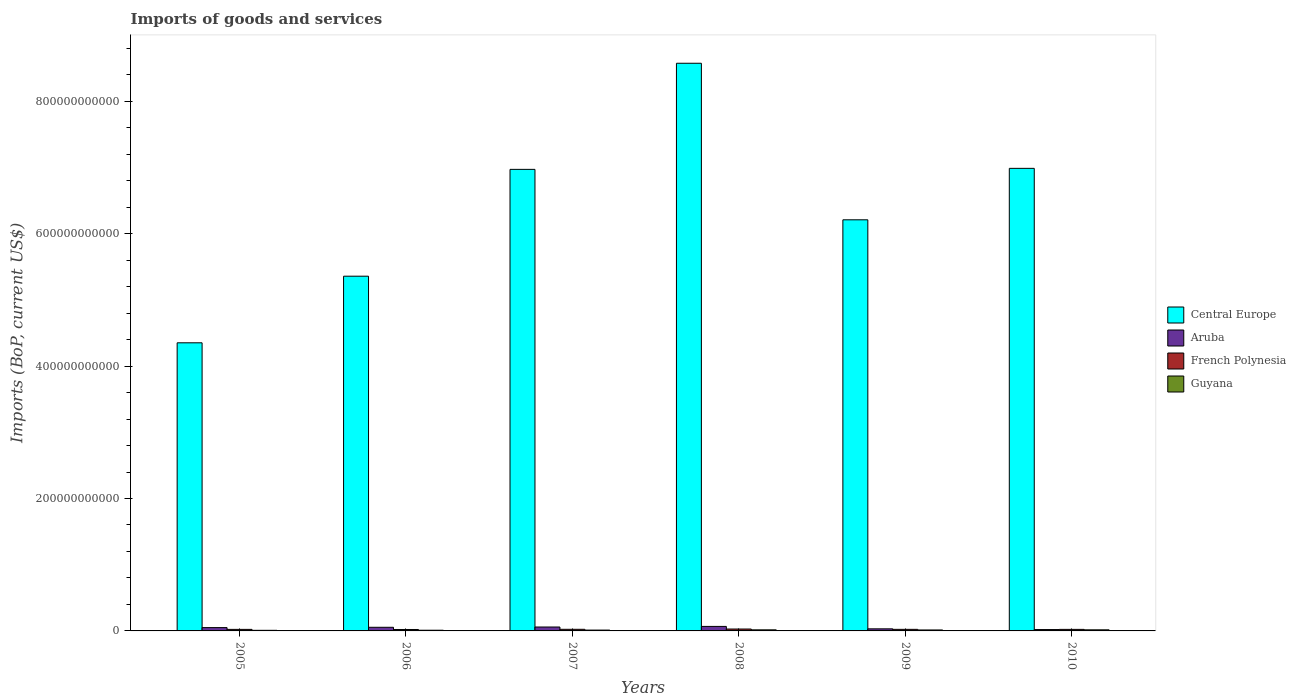How many different coloured bars are there?
Offer a terse response. 4. How many groups of bars are there?
Your response must be concise. 6. Are the number of bars per tick equal to the number of legend labels?
Your answer should be very brief. Yes. In how many cases, is the number of bars for a given year not equal to the number of legend labels?
Your answer should be very brief. 0. What is the amount spent on imports in French Polynesia in 2005?
Provide a succinct answer. 2.31e+09. Across all years, what is the maximum amount spent on imports in French Polynesia?
Offer a terse response. 2.87e+09. Across all years, what is the minimum amount spent on imports in Guyana?
Give a very brief answer. 9.18e+08. In which year was the amount spent on imports in Guyana maximum?
Provide a succinct answer. 2010. In which year was the amount spent on imports in Central Europe minimum?
Offer a terse response. 2005. What is the total amount spent on imports in French Polynesia in the graph?
Provide a short and direct response. 1.45e+1. What is the difference between the amount spent on imports in Aruba in 2006 and that in 2008?
Make the answer very short. -1.33e+09. What is the difference between the amount spent on imports in Guyana in 2007 and the amount spent on imports in Central Europe in 2006?
Offer a very short reply. -5.35e+11. What is the average amount spent on imports in Central Europe per year?
Keep it short and to the point. 6.41e+11. In the year 2006, what is the difference between the amount spent on imports in Aruba and amount spent on imports in Central Europe?
Offer a very short reply. -5.30e+11. In how many years, is the amount spent on imports in Central Europe greater than 840000000000 US$?
Keep it short and to the point. 1. What is the ratio of the amount spent on imports in Central Europe in 2009 to that in 2010?
Keep it short and to the point. 0.89. Is the amount spent on imports in Central Europe in 2005 less than that in 2008?
Offer a terse response. Yes. Is the difference between the amount spent on imports in Aruba in 2009 and 2010 greater than the difference between the amount spent on imports in Central Europe in 2009 and 2010?
Your response must be concise. Yes. What is the difference between the highest and the second highest amount spent on imports in Guyana?
Offer a terse response. 8.76e+06. What is the difference between the highest and the lowest amount spent on imports in French Polynesia?
Make the answer very short. 7.10e+08. What does the 1st bar from the left in 2007 represents?
Provide a short and direct response. Central Europe. What does the 3rd bar from the right in 2008 represents?
Your response must be concise. Aruba. How many bars are there?
Provide a succinct answer. 24. Are all the bars in the graph horizontal?
Make the answer very short. No. How many years are there in the graph?
Keep it short and to the point. 6. What is the difference between two consecutive major ticks on the Y-axis?
Keep it short and to the point. 2.00e+11. Are the values on the major ticks of Y-axis written in scientific E-notation?
Ensure brevity in your answer.  No. Where does the legend appear in the graph?
Give a very brief answer. Center right. What is the title of the graph?
Provide a succinct answer. Imports of goods and services. What is the label or title of the Y-axis?
Give a very brief answer. Imports (BoP, current US$). What is the Imports (BoP, current US$) in Central Europe in 2005?
Offer a very short reply. 4.35e+11. What is the Imports (BoP, current US$) of Aruba in 2005?
Your response must be concise. 5.01e+09. What is the Imports (BoP, current US$) in French Polynesia in 2005?
Provide a short and direct response. 2.31e+09. What is the Imports (BoP, current US$) in Guyana in 2005?
Your response must be concise. 9.18e+08. What is the Imports (BoP, current US$) in Central Europe in 2006?
Offer a terse response. 5.36e+11. What is the Imports (BoP, current US$) of Aruba in 2006?
Your answer should be compact. 5.48e+09. What is the Imports (BoP, current US$) of French Polynesia in 2006?
Your answer should be very brief. 2.16e+09. What is the Imports (BoP, current US$) in Guyana in 2006?
Offer a very short reply. 1.06e+09. What is the Imports (BoP, current US$) of Central Europe in 2007?
Your answer should be compact. 6.97e+11. What is the Imports (BoP, current US$) in Aruba in 2007?
Provide a succinct answer. 5.91e+09. What is the Imports (BoP, current US$) in French Polynesia in 2007?
Provide a short and direct response. 2.43e+09. What is the Imports (BoP, current US$) of Guyana in 2007?
Your response must be concise. 1.26e+09. What is the Imports (BoP, current US$) of Central Europe in 2008?
Offer a terse response. 8.57e+11. What is the Imports (BoP, current US$) of Aruba in 2008?
Provide a succinct answer. 6.81e+09. What is the Imports (BoP, current US$) of French Polynesia in 2008?
Keep it short and to the point. 2.87e+09. What is the Imports (BoP, current US$) in Guyana in 2008?
Provide a short and direct response. 1.65e+09. What is the Imports (BoP, current US$) in Central Europe in 2009?
Give a very brief answer. 6.21e+11. What is the Imports (BoP, current US$) in Aruba in 2009?
Make the answer very short. 3.15e+09. What is the Imports (BoP, current US$) in French Polynesia in 2009?
Your response must be concise. 2.38e+09. What is the Imports (BoP, current US$) of Guyana in 2009?
Offer a terse response. 1.45e+09. What is the Imports (BoP, current US$) of Central Europe in 2010?
Ensure brevity in your answer.  6.99e+11. What is the Imports (BoP, current US$) in Aruba in 2010?
Your answer should be compact. 2.07e+09. What is the Imports (BoP, current US$) in French Polynesia in 2010?
Your response must be concise. 2.33e+09. What is the Imports (BoP, current US$) in Guyana in 2010?
Keep it short and to the point. 1.66e+09. Across all years, what is the maximum Imports (BoP, current US$) in Central Europe?
Provide a short and direct response. 8.57e+11. Across all years, what is the maximum Imports (BoP, current US$) of Aruba?
Provide a succinct answer. 6.81e+09. Across all years, what is the maximum Imports (BoP, current US$) in French Polynesia?
Your answer should be compact. 2.87e+09. Across all years, what is the maximum Imports (BoP, current US$) of Guyana?
Ensure brevity in your answer.  1.66e+09. Across all years, what is the minimum Imports (BoP, current US$) of Central Europe?
Give a very brief answer. 4.35e+11. Across all years, what is the minimum Imports (BoP, current US$) in Aruba?
Ensure brevity in your answer.  2.07e+09. Across all years, what is the minimum Imports (BoP, current US$) of French Polynesia?
Your answer should be compact. 2.16e+09. Across all years, what is the minimum Imports (BoP, current US$) in Guyana?
Make the answer very short. 9.18e+08. What is the total Imports (BoP, current US$) of Central Europe in the graph?
Your response must be concise. 3.85e+12. What is the total Imports (BoP, current US$) in Aruba in the graph?
Offer a terse response. 2.84e+1. What is the total Imports (BoP, current US$) in French Polynesia in the graph?
Your answer should be compact. 1.45e+1. What is the total Imports (BoP, current US$) of Guyana in the graph?
Provide a short and direct response. 7.99e+09. What is the difference between the Imports (BoP, current US$) of Central Europe in 2005 and that in 2006?
Provide a short and direct response. -1.01e+11. What is the difference between the Imports (BoP, current US$) of Aruba in 2005 and that in 2006?
Make the answer very short. -4.72e+08. What is the difference between the Imports (BoP, current US$) of French Polynesia in 2005 and that in 2006?
Make the answer very short. 1.59e+08. What is the difference between the Imports (BoP, current US$) of Guyana in 2005 and that in 2006?
Your answer should be very brief. -1.37e+08. What is the difference between the Imports (BoP, current US$) of Central Europe in 2005 and that in 2007?
Keep it short and to the point. -2.62e+11. What is the difference between the Imports (BoP, current US$) in Aruba in 2005 and that in 2007?
Your answer should be very brief. -9.04e+08. What is the difference between the Imports (BoP, current US$) in French Polynesia in 2005 and that in 2007?
Make the answer very short. -1.17e+08. What is the difference between the Imports (BoP, current US$) in Guyana in 2005 and that in 2007?
Your answer should be very brief. -3.37e+08. What is the difference between the Imports (BoP, current US$) in Central Europe in 2005 and that in 2008?
Your answer should be compact. -4.22e+11. What is the difference between the Imports (BoP, current US$) in Aruba in 2005 and that in 2008?
Offer a terse response. -1.80e+09. What is the difference between the Imports (BoP, current US$) of French Polynesia in 2005 and that in 2008?
Your response must be concise. -5.50e+08. What is the difference between the Imports (BoP, current US$) of Guyana in 2005 and that in 2008?
Your answer should be very brief. -7.31e+08. What is the difference between the Imports (BoP, current US$) of Central Europe in 2005 and that in 2009?
Offer a very short reply. -1.86e+11. What is the difference between the Imports (BoP, current US$) of Aruba in 2005 and that in 2009?
Make the answer very short. 1.86e+09. What is the difference between the Imports (BoP, current US$) in French Polynesia in 2005 and that in 2009?
Your answer should be compact. -6.25e+07. What is the difference between the Imports (BoP, current US$) in Guyana in 2005 and that in 2009?
Provide a short and direct response. -5.34e+08. What is the difference between the Imports (BoP, current US$) in Central Europe in 2005 and that in 2010?
Offer a terse response. -2.63e+11. What is the difference between the Imports (BoP, current US$) of Aruba in 2005 and that in 2010?
Make the answer very short. 2.93e+09. What is the difference between the Imports (BoP, current US$) in French Polynesia in 2005 and that in 2010?
Give a very brief answer. -1.53e+07. What is the difference between the Imports (BoP, current US$) in Guyana in 2005 and that in 2010?
Make the answer very short. -7.40e+08. What is the difference between the Imports (BoP, current US$) of Central Europe in 2006 and that in 2007?
Offer a very short reply. -1.61e+11. What is the difference between the Imports (BoP, current US$) in Aruba in 2006 and that in 2007?
Provide a short and direct response. -4.32e+08. What is the difference between the Imports (BoP, current US$) of French Polynesia in 2006 and that in 2007?
Give a very brief answer. -2.76e+08. What is the difference between the Imports (BoP, current US$) of Guyana in 2006 and that in 2007?
Provide a succinct answer. -2.00e+08. What is the difference between the Imports (BoP, current US$) of Central Europe in 2006 and that in 2008?
Ensure brevity in your answer.  -3.22e+11. What is the difference between the Imports (BoP, current US$) of Aruba in 2006 and that in 2008?
Make the answer very short. -1.33e+09. What is the difference between the Imports (BoP, current US$) in French Polynesia in 2006 and that in 2008?
Keep it short and to the point. -7.10e+08. What is the difference between the Imports (BoP, current US$) in Guyana in 2006 and that in 2008?
Offer a very short reply. -5.94e+08. What is the difference between the Imports (BoP, current US$) of Central Europe in 2006 and that in 2009?
Give a very brief answer. -8.52e+1. What is the difference between the Imports (BoP, current US$) of Aruba in 2006 and that in 2009?
Provide a short and direct response. 2.33e+09. What is the difference between the Imports (BoP, current US$) in French Polynesia in 2006 and that in 2009?
Make the answer very short. -2.22e+08. What is the difference between the Imports (BoP, current US$) of Guyana in 2006 and that in 2009?
Your response must be concise. -3.97e+08. What is the difference between the Imports (BoP, current US$) of Central Europe in 2006 and that in 2010?
Give a very brief answer. -1.63e+11. What is the difference between the Imports (BoP, current US$) in Aruba in 2006 and that in 2010?
Your answer should be compact. 3.41e+09. What is the difference between the Imports (BoP, current US$) in French Polynesia in 2006 and that in 2010?
Make the answer very short. -1.75e+08. What is the difference between the Imports (BoP, current US$) of Guyana in 2006 and that in 2010?
Give a very brief answer. -6.02e+08. What is the difference between the Imports (BoP, current US$) of Central Europe in 2007 and that in 2008?
Provide a short and direct response. -1.60e+11. What is the difference between the Imports (BoP, current US$) in Aruba in 2007 and that in 2008?
Give a very brief answer. -9.00e+08. What is the difference between the Imports (BoP, current US$) of French Polynesia in 2007 and that in 2008?
Provide a succinct answer. -4.33e+08. What is the difference between the Imports (BoP, current US$) of Guyana in 2007 and that in 2008?
Your response must be concise. -3.93e+08. What is the difference between the Imports (BoP, current US$) in Central Europe in 2007 and that in 2009?
Offer a terse response. 7.62e+1. What is the difference between the Imports (BoP, current US$) of Aruba in 2007 and that in 2009?
Provide a short and direct response. 2.77e+09. What is the difference between the Imports (BoP, current US$) in French Polynesia in 2007 and that in 2009?
Keep it short and to the point. 5.44e+07. What is the difference between the Imports (BoP, current US$) of Guyana in 2007 and that in 2009?
Keep it short and to the point. -1.96e+08. What is the difference between the Imports (BoP, current US$) of Central Europe in 2007 and that in 2010?
Your answer should be very brief. -1.54e+09. What is the difference between the Imports (BoP, current US$) of Aruba in 2007 and that in 2010?
Provide a short and direct response. 3.84e+09. What is the difference between the Imports (BoP, current US$) in French Polynesia in 2007 and that in 2010?
Provide a succinct answer. 1.02e+08. What is the difference between the Imports (BoP, current US$) in Guyana in 2007 and that in 2010?
Offer a very short reply. -4.02e+08. What is the difference between the Imports (BoP, current US$) of Central Europe in 2008 and that in 2009?
Your answer should be very brief. 2.36e+11. What is the difference between the Imports (BoP, current US$) of Aruba in 2008 and that in 2009?
Your answer should be very brief. 3.67e+09. What is the difference between the Imports (BoP, current US$) in French Polynesia in 2008 and that in 2009?
Provide a succinct answer. 4.88e+08. What is the difference between the Imports (BoP, current US$) in Guyana in 2008 and that in 2009?
Offer a terse response. 1.97e+08. What is the difference between the Imports (BoP, current US$) in Central Europe in 2008 and that in 2010?
Make the answer very short. 1.59e+11. What is the difference between the Imports (BoP, current US$) of Aruba in 2008 and that in 2010?
Offer a terse response. 4.74e+09. What is the difference between the Imports (BoP, current US$) of French Polynesia in 2008 and that in 2010?
Your answer should be compact. 5.35e+08. What is the difference between the Imports (BoP, current US$) of Guyana in 2008 and that in 2010?
Offer a terse response. -8.76e+06. What is the difference between the Imports (BoP, current US$) in Central Europe in 2009 and that in 2010?
Ensure brevity in your answer.  -7.77e+1. What is the difference between the Imports (BoP, current US$) of Aruba in 2009 and that in 2010?
Offer a terse response. 1.07e+09. What is the difference between the Imports (BoP, current US$) of French Polynesia in 2009 and that in 2010?
Offer a terse response. 4.72e+07. What is the difference between the Imports (BoP, current US$) in Guyana in 2009 and that in 2010?
Provide a succinct answer. -2.06e+08. What is the difference between the Imports (BoP, current US$) in Central Europe in 2005 and the Imports (BoP, current US$) in Aruba in 2006?
Your response must be concise. 4.30e+11. What is the difference between the Imports (BoP, current US$) in Central Europe in 2005 and the Imports (BoP, current US$) in French Polynesia in 2006?
Offer a terse response. 4.33e+11. What is the difference between the Imports (BoP, current US$) in Central Europe in 2005 and the Imports (BoP, current US$) in Guyana in 2006?
Offer a very short reply. 4.34e+11. What is the difference between the Imports (BoP, current US$) in Aruba in 2005 and the Imports (BoP, current US$) in French Polynesia in 2006?
Your answer should be compact. 2.85e+09. What is the difference between the Imports (BoP, current US$) in Aruba in 2005 and the Imports (BoP, current US$) in Guyana in 2006?
Provide a succinct answer. 3.95e+09. What is the difference between the Imports (BoP, current US$) of French Polynesia in 2005 and the Imports (BoP, current US$) of Guyana in 2006?
Ensure brevity in your answer.  1.26e+09. What is the difference between the Imports (BoP, current US$) of Central Europe in 2005 and the Imports (BoP, current US$) of Aruba in 2007?
Your answer should be compact. 4.29e+11. What is the difference between the Imports (BoP, current US$) of Central Europe in 2005 and the Imports (BoP, current US$) of French Polynesia in 2007?
Your answer should be compact. 4.33e+11. What is the difference between the Imports (BoP, current US$) in Central Europe in 2005 and the Imports (BoP, current US$) in Guyana in 2007?
Give a very brief answer. 4.34e+11. What is the difference between the Imports (BoP, current US$) in Aruba in 2005 and the Imports (BoP, current US$) in French Polynesia in 2007?
Provide a short and direct response. 2.58e+09. What is the difference between the Imports (BoP, current US$) of Aruba in 2005 and the Imports (BoP, current US$) of Guyana in 2007?
Make the answer very short. 3.75e+09. What is the difference between the Imports (BoP, current US$) in French Polynesia in 2005 and the Imports (BoP, current US$) in Guyana in 2007?
Your answer should be compact. 1.06e+09. What is the difference between the Imports (BoP, current US$) in Central Europe in 2005 and the Imports (BoP, current US$) in Aruba in 2008?
Make the answer very short. 4.28e+11. What is the difference between the Imports (BoP, current US$) of Central Europe in 2005 and the Imports (BoP, current US$) of French Polynesia in 2008?
Give a very brief answer. 4.32e+11. What is the difference between the Imports (BoP, current US$) of Central Europe in 2005 and the Imports (BoP, current US$) of Guyana in 2008?
Ensure brevity in your answer.  4.34e+11. What is the difference between the Imports (BoP, current US$) of Aruba in 2005 and the Imports (BoP, current US$) of French Polynesia in 2008?
Your answer should be compact. 2.14e+09. What is the difference between the Imports (BoP, current US$) of Aruba in 2005 and the Imports (BoP, current US$) of Guyana in 2008?
Make the answer very short. 3.36e+09. What is the difference between the Imports (BoP, current US$) in French Polynesia in 2005 and the Imports (BoP, current US$) in Guyana in 2008?
Ensure brevity in your answer.  6.66e+08. What is the difference between the Imports (BoP, current US$) of Central Europe in 2005 and the Imports (BoP, current US$) of Aruba in 2009?
Offer a very short reply. 4.32e+11. What is the difference between the Imports (BoP, current US$) in Central Europe in 2005 and the Imports (BoP, current US$) in French Polynesia in 2009?
Ensure brevity in your answer.  4.33e+11. What is the difference between the Imports (BoP, current US$) of Central Europe in 2005 and the Imports (BoP, current US$) of Guyana in 2009?
Offer a terse response. 4.34e+11. What is the difference between the Imports (BoP, current US$) in Aruba in 2005 and the Imports (BoP, current US$) in French Polynesia in 2009?
Offer a very short reply. 2.63e+09. What is the difference between the Imports (BoP, current US$) in Aruba in 2005 and the Imports (BoP, current US$) in Guyana in 2009?
Your response must be concise. 3.56e+09. What is the difference between the Imports (BoP, current US$) in French Polynesia in 2005 and the Imports (BoP, current US$) in Guyana in 2009?
Provide a short and direct response. 8.63e+08. What is the difference between the Imports (BoP, current US$) of Central Europe in 2005 and the Imports (BoP, current US$) of Aruba in 2010?
Make the answer very short. 4.33e+11. What is the difference between the Imports (BoP, current US$) of Central Europe in 2005 and the Imports (BoP, current US$) of French Polynesia in 2010?
Provide a succinct answer. 4.33e+11. What is the difference between the Imports (BoP, current US$) of Central Europe in 2005 and the Imports (BoP, current US$) of Guyana in 2010?
Give a very brief answer. 4.34e+11. What is the difference between the Imports (BoP, current US$) in Aruba in 2005 and the Imports (BoP, current US$) in French Polynesia in 2010?
Provide a succinct answer. 2.68e+09. What is the difference between the Imports (BoP, current US$) of Aruba in 2005 and the Imports (BoP, current US$) of Guyana in 2010?
Your answer should be compact. 3.35e+09. What is the difference between the Imports (BoP, current US$) of French Polynesia in 2005 and the Imports (BoP, current US$) of Guyana in 2010?
Your answer should be compact. 6.57e+08. What is the difference between the Imports (BoP, current US$) of Central Europe in 2006 and the Imports (BoP, current US$) of Aruba in 2007?
Your response must be concise. 5.30e+11. What is the difference between the Imports (BoP, current US$) in Central Europe in 2006 and the Imports (BoP, current US$) in French Polynesia in 2007?
Provide a succinct answer. 5.33e+11. What is the difference between the Imports (BoP, current US$) in Central Europe in 2006 and the Imports (BoP, current US$) in Guyana in 2007?
Provide a succinct answer. 5.35e+11. What is the difference between the Imports (BoP, current US$) of Aruba in 2006 and the Imports (BoP, current US$) of French Polynesia in 2007?
Your answer should be compact. 3.05e+09. What is the difference between the Imports (BoP, current US$) of Aruba in 2006 and the Imports (BoP, current US$) of Guyana in 2007?
Ensure brevity in your answer.  4.22e+09. What is the difference between the Imports (BoP, current US$) of French Polynesia in 2006 and the Imports (BoP, current US$) of Guyana in 2007?
Your answer should be compact. 9.00e+08. What is the difference between the Imports (BoP, current US$) in Central Europe in 2006 and the Imports (BoP, current US$) in Aruba in 2008?
Ensure brevity in your answer.  5.29e+11. What is the difference between the Imports (BoP, current US$) in Central Europe in 2006 and the Imports (BoP, current US$) in French Polynesia in 2008?
Keep it short and to the point. 5.33e+11. What is the difference between the Imports (BoP, current US$) in Central Europe in 2006 and the Imports (BoP, current US$) in Guyana in 2008?
Keep it short and to the point. 5.34e+11. What is the difference between the Imports (BoP, current US$) of Aruba in 2006 and the Imports (BoP, current US$) of French Polynesia in 2008?
Your response must be concise. 2.61e+09. What is the difference between the Imports (BoP, current US$) in Aruba in 2006 and the Imports (BoP, current US$) in Guyana in 2008?
Offer a terse response. 3.83e+09. What is the difference between the Imports (BoP, current US$) in French Polynesia in 2006 and the Imports (BoP, current US$) in Guyana in 2008?
Your answer should be very brief. 5.07e+08. What is the difference between the Imports (BoP, current US$) of Central Europe in 2006 and the Imports (BoP, current US$) of Aruba in 2009?
Keep it short and to the point. 5.33e+11. What is the difference between the Imports (BoP, current US$) of Central Europe in 2006 and the Imports (BoP, current US$) of French Polynesia in 2009?
Offer a terse response. 5.33e+11. What is the difference between the Imports (BoP, current US$) in Central Europe in 2006 and the Imports (BoP, current US$) in Guyana in 2009?
Keep it short and to the point. 5.34e+11. What is the difference between the Imports (BoP, current US$) of Aruba in 2006 and the Imports (BoP, current US$) of French Polynesia in 2009?
Make the answer very short. 3.10e+09. What is the difference between the Imports (BoP, current US$) of Aruba in 2006 and the Imports (BoP, current US$) of Guyana in 2009?
Give a very brief answer. 4.03e+09. What is the difference between the Imports (BoP, current US$) in French Polynesia in 2006 and the Imports (BoP, current US$) in Guyana in 2009?
Keep it short and to the point. 7.04e+08. What is the difference between the Imports (BoP, current US$) of Central Europe in 2006 and the Imports (BoP, current US$) of Aruba in 2010?
Make the answer very short. 5.34e+11. What is the difference between the Imports (BoP, current US$) of Central Europe in 2006 and the Imports (BoP, current US$) of French Polynesia in 2010?
Your answer should be compact. 5.33e+11. What is the difference between the Imports (BoP, current US$) in Central Europe in 2006 and the Imports (BoP, current US$) in Guyana in 2010?
Your answer should be very brief. 5.34e+11. What is the difference between the Imports (BoP, current US$) of Aruba in 2006 and the Imports (BoP, current US$) of French Polynesia in 2010?
Offer a terse response. 3.15e+09. What is the difference between the Imports (BoP, current US$) of Aruba in 2006 and the Imports (BoP, current US$) of Guyana in 2010?
Give a very brief answer. 3.82e+09. What is the difference between the Imports (BoP, current US$) in French Polynesia in 2006 and the Imports (BoP, current US$) in Guyana in 2010?
Offer a very short reply. 4.98e+08. What is the difference between the Imports (BoP, current US$) in Central Europe in 2007 and the Imports (BoP, current US$) in Aruba in 2008?
Provide a succinct answer. 6.90e+11. What is the difference between the Imports (BoP, current US$) in Central Europe in 2007 and the Imports (BoP, current US$) in French Polynesia in 2008?
Your response must be concise. 6.94e+11. What is the difference between the Imports (BoP, current US$) in Central Europe in 2007 and the Imports (BoP, current US$) in Guyana in 2008?
Your answer should be very brief. 6.95e+11. What is the difference between the Imports (BoP, current US$) of Aruba in 2007 and the Imports (BoP, current US$) of French Polynesia in 2008?
Offer a terse response. 3.05e+09. What is the difference between the Imports (BoP, current US$) of Aruba in 2007 and the Imports (BoP, current US$) of Guyana in 2008?
Keep it short and to the point. 4.26e+09. What is the difference between the Imports (BoP, current US$) of French Polynesia in 2007 and the Imports (BoP, current US$) of Guyana in 2008?
Offer a very short reply. 7.83e+08. What is the difference between the Imports (BoP, current US$) of Central Europe in 2007 and the Imports (BoP, current US$) of Aruba in 2009?
Make the answer very short. 6.94e+11. What is the difference between the Imports (BoP, current US$) of Central Europe in 2007 and the Imports (BoP, current US$) of French Polynesia in 2009?
Your answer should be very brief. 6.95e+11. What is the difference between the Imports (BoP, current US$) in Central Europe in 2007 and the Imports (BoP, current US$) in Guyana in 2009?
Keep it short and to the point. 6.96e+11. What is the difference between the Imports (BoP, current US$) of Aruba in 2007 and the Imports (BoP, current US$) of French Polynesia in 2009?
Provide a succinct answer. 3.53e+09. What is the difference between the Imports (BoP, current US$) of Aruba in 2007 and the Imports (BoP, current US$) of Guyana in 2009?
Your answer should be compact. 4.46e+09. What is the difference between the Imports (BoP, current US$) in French Polynesia in 2007 and the Imports (BoP, current US$) in Guyana in 2009?
Offer a very short reply. 9.80e+08. What is the difference between the Imports (BoP, current US$) in Central Europe in 2007 and the Imports (BoP, current US$) in Aruba in 2010?
Give a very brief answer. 6.95e+11. What is the difference between the Imports (BoP, current US$) in Central Europe in 2007 and the Imports (BoP, current US$) in French Polynesia in 2010?
Your response must be concise. 6.95e+11. What is the difference between the Imports (BoP, current US$) in Central Europe in 2007 and the Imports (BoP, current US$) in Guyana in 2010?
Your answer should be compact. 6.95e+11. What is the difference between the Imports (BoP, current US$) of Aruba in 2007 and the Imports (BoP, current US$) of French Polynesia in 2010?
Your answer should be compact. 3.58e+09. What is the difference between the Imports (BoP, current US$) of Aruba in 2007 and the Imports (BoP, current US$) of Guyana in 2010?
Provide a short and direct response. 4.25e+09. What is the difference between the Imports (BoP, current US$) in French Polynesia in 2007 and the Imports (BoP, current US$) in Guyana in 2010?
Your answer should be compact. 7.74e+08. What is the difference between the Imports (BoP, current US$) of Central Europe in 2008 and the Imports (BoP, current US$) of Aruba in 2009?
Your answer should be very brief. 8.54e+11. What is the difference between the Imports (BoP, current US$) of Central Europe in 2008 and the Imports (BoP, current US$) of French Polynesia in 2009?
Keep it short and to the point. 8.55e+11. What is the difference between the Imports (BoP, current US$) of Central Europe in 2008 and the Imports (BoP, current US$) of Guyana in 2009?
Your response must be concise. 8.56e+11. What is the difference between the Imports (BoP, current US$) of Aruba in 2008 and the Imports (BoP, current US$) of French Polynesia in 2009?
Offer a terse response. 4.43e+09. What is the difference between the Imports (BoP, current US$) of Aruba in 2008 and the Imports (BoP, current US$) of Guyana in 2009?
Your answer should be compact. 5.36e+09. What is the difference between the Imports (BoP, current US$) in French Polynesia in 2008 and the Imports (BoP, current US$) in Guyana in 2009?
Make the answer very short. 1.41e+09. What is the difference between the Imports (BoP, current US$) in Central Europe in 2008 and the Imports (BoP, current US$) in Aruba in 2010?
Offer a very short reply. 8.55e+11. What is the difference between the Imports (BoP, current US$) in Central Europe in 2008 and the Imports (BoP, current US$) in French Polynesia in 2010?
Provide a short and direct response. 8.55e+11. What is the difference between the Imports (BoP, current US$) in Central Europe in 2008 and the Imports (BoP, current US$) in Guyana in 2010?
Keep it short and to the point. 8.56e+11. What is the difference between the Imports (BoP, current US$) in Aruba in 2008 and the Imports (BoP, current US$) in French Polynesia in 2010?
Keep it short and to the point. 4.48e+09. What is the difference between the Imports (BoP, current US$) of Aruba in 2008 and the Imports (BoP, current US$) of Guyana in 2010?
Your answer should be compact. 5.15e+09. What is the difference between the Imports (BoP, current US$) of French Polynesia in 2008 and the Imports (BoP, current US$) of Guyana in 2010?
Your response must be concise. 1.21e+09. What is the difference between the Imports (BoP, current US$) of Central Europe in 2009 and the Imports (BoP, current US$) of Aruba in 2010?
Your answer should be very brief. 6.19e+11. What is the difference between the Imports (BoP, current US$) in Central Europe in 2009 and the Imports (BoP, current US$) in French Polynesia in 2010?
Offer a very short reply. 6.19e+11. What is the difference between the Imports (BoP, current US$) in Central Europe in 2009 and the Imports (BoP, current US$) in Guyana in 2010?
Ensure brevity in your answer.  6.19e+11. What is the difference between the Imports (BoP, current US$) of Aruba in 2009 and the Imports (BoP, current US$) of French Polynesia in 2010?
Offer a very short reply. 8.16e+08. What is the difference between the Imports (BoP, current US$) in Aruba in 2009 and the Imports (BoP, current US$) in Guyana in 2010?
Your answer should be very brief. 1.49e+09. What is the difference between the Imports (BoP, current US$) in French Polynesia in 2009 and the Imports (BoP, current US$) in Guyana in 2010?
Provide a short and direct response. 7.20e+08. What is the average Imports (BoP, current US$) in Central Europe per year?
Give a very brief answer. 6.41e+11. What is the average Imports (BoP, current US$) of Aruba per year?
Offer a terse response. 4.74e+09. What is the average Imports (BoP, current US$) in French Polynesia per year?
Your response must be concise. 2.41e+09. What is the average Imports (BoP, current US$) in Guyana per year?
Your answer should be compact. 1.33e+09. In the year 2005, what is the difference between the Imports (BoP, current US$) in Central Europe and Imports (BoP, current US$) in Aruba?
Offer a very short reply. 4.30e+11. In the year 2005, what is the difference between the Imports (BoP, current US$) in Central Europe and Imports (BoP, current US$) in French Polynesia?
Your response must be concise. 4.33e+11. In the year 2005, what is the difference between the Imports (BoP, current US$) of Central Europe and Imports (BoP, current US$) of Guyana?
Give a very brief answer. 4.34e+11. In the year 2005, what is the difference between the Imports (BoP, current US$) of Aruba and Imports (BoP, current US$) of French Polynesia?
Your answer should be compact. 2.69e+09. In the year 2005, what is the difference between the Imports (BoP, current US$) in Aruba and Imports (BoP, current US$) in Guyana?
Provide a succinct answer. 4.09e+09. In the year 2005, what is the difference between the Imports (BoP, current US$) of French Polynesia and Imports (BoP, current US$) of Guyana?
Provide a succinct answer. 1.40e+09. In the year 2006, what is the difference between the Imports (BoP, current US$) of Central Europe and Imports (BoP, current US$) of Aruba?
Provide a succinct answer. 5.30e+11. In the year 2006, what is the difference between the Imports (BoP, current US$) in Central Europe and Imports (BoP, current US$) in French Polynesia?
Provide a succinct answer. 5.34e+11. In the year 2006, what is the difference between the Imports (BoP, current US$) in Central Europe and Imports (BoP, current US$) in Guyana?
Provide a succinct answer. 5.35e+11. In the year 2006, what is the difference between the Imports (BoP, current US$) in Aruba and Imports (BoP, current US$) in French Polynesia?
Offer a terse response. 3.32e+09. In the year 2006, what is the difference between the Imports (BoP, current US$) of Aruba and Imports (BoP, current US$) of Guyana?
Your response must be concise. 4.42e+09. In the year 2006, what is the difference between the Imports (BoP, current US$) of French Polynesia and Imports (BoP, current US$) of Guyana?
Your answer should be very brief. 1.10e+09. In the year 2007, what is the difference between the Imports (BoP, current US$) of Central Europe and Imports (BoP, current US$) of Aruba?
Make the answer very short. 6.91e+11. In the year 2007, what is the difference between the Imports (BoP, current US$) in Central Europe and Imports (BoP, current US$) in French Polynesia?
Provide a short and direct response. 6.95e+11. In the year 2007, what is the difference between the Imports (BoP, current US$) of Central Europe and Imports (BoP, current US$) of Guyana?
Your answer should be very brief. 6.96e+11. In the year 2007, what is the difference between the Imports (BoP, current US$) in Aruba and Imports (BoP, current US$) in French Polynesia?
Provide a short and direct response. 3.48e+09. In the year 2007, what is the difference between the Imports (BoP, current US$) of Aruba and Imports (BoP, current US$) of Guyana?
Offer a terse response. 4.66e+09. In the year 2007, what is the difference between the Imports (BoP, current US$) of French Polynesia and Imports (BoP, current US$) of Guyana?
Give a very brief answer. 1.18e+09. In the year 2008, what is the difference between the Imports (BoP, current US$) in Central Europe and Imports (BoP, current US$) in Aruba?
Give a very brief answer. 8.51e+11. In the year 2008, what is the difference between the Imports (BoP, current US$) of Central Europe and Imports (BoP, current US$) of French Polynesia?
Your answer should be very brief. 8.55e+11. In the year 2008, what is the difference between the Imports (BoP, current US$) in Central Europe and Imports (BoP, current US$) in Guyana?
Your answer should be compact. 8.56e+11. In the year 2008, what is the difference between the Imports (BoP, current US$) of Aruba and Imports (BoP, current US$) of French Polynesia?
Offer a terse response. 3.95e+09. In the year 2008, what is the difference between the Imports (BoP, current US$) in Aruba and Imports (BoP, current US$) in Guyana?
Your response must be concise. 5.16e+09. In the year 2008, what is the difference between the Imports (BoP, current US$) of French Polynesia and Imports (BoP, current US$) of Guyana?
Provide a short and direct response. 1.22e+09. In the year 2009, what is the difference between the Imports (BoP, current US$) of Central Europe and Imports (BoP, current US$) of Aruba?
Your answer should be very brief. 6.18e+11. In the year 2009, what is the difference between the Imports (BoP, current US$) in Central Europe and Imports (BoP, current US$) in French Polynesia?
Your response must be concise. 6.19e+11. In the year 2009, what is the difference between the Imports (BoP, current US$) in Central Europe and Imports (BoP, current US$) in Guyana?
Your response must be concise. 6.19e+11. In the year 2009, what is the difference between the Imports (BoP, current US$) in Aruba and Imports (BoP, current US$) in French Polynesia?
Give a very brief answer. 7.69e+08. In the year 2009, what is the difference between the Imports (BoP, current US$) of Aruba and Imports (BoP, current US$) of Guyana?
Keep it short and to the point. 1.69e+09. In the year 2009, what is the difference between the Imports (BoP, current US$) of French Polynesia and Imports (BoP, current US$) of Guyana?
Provide a short and direct response. 9.25e+08. In the year 2010, what is the difference between the Imports (BoP, current US$) of Central Europe and Imports (BoP, current US$) of Aruba?
Give a very brief answer. 6.97e+11. In the year 2010, what is the difference between the Imports (BoP, current US$) of Central Europe and Imports (BoP, current US$) of French Polynesia?
Provide a short and direct response. 6.96e+11. In the year 2010, what is the difference between the Imports (BoP, current US$) of Central Europe and Imports (BoP, current US$) of Guyana?
Ensure brevity in your answer.  6.97e+11. In the year 2010, what is the difference between the Imports (BoP, current US$) of Aruba and Imports (BoP, current US$) of French Polynesia?
Ensure brevity in your answer.  -2.56e+08. In the year 2010, what is the difference between the Imports (BoP, current US$) of Aruba and Imports (BoP, current US$) of Guyana?
Keep it short and to the point. 4.16e+08. In the year 2010, what is the difference between the Imports (BoP, current US$) of French Polynesia and Imports (BoP, current US$) of Guyana?
Make the answer very short. 6.73e+08. What is the ratio of the Imports (BoP, current US$) in Central Europe in 2005 to that in 2006?
Offer a very short reply. 0.81. What is the ratio of the Imports (BoP, current US$) of Aruba in 2005 to that in 2006?
Ensure brevity in your answer.  0.91. What is the ratio of the Imports (BoP, current US$) in French Polynesia in 2005 to that in 2006?
Your answer should be compact. 1.07. What is the ratio of the Imports (BoP, current US$) of Guyana in 2005 to that in 2006?
Keep it short and to the point. 0.87. What is the ratio of the Imports (BoP, current US$) in Central Europe in 2005 to that in 2007?
Offer a terse response. 0.62. What is the ratio of the Imports (BoP, current US$) in Aruba in 2005 to that in 2007?
Ensure brevity in your answer.  0.85. What is the ratio of the Imports (BoP, current US$) in French Polynesia in 2005 to that in 2007?
Your response must be concise. 0.95. What is the ratio of the Imports (BoP, current US$) in Guyana in 2005 to that in 2007?
Provide a succinct answer. 0.73. What is the ratio of the Imports (BoP, current US$) in Central Europe in 2005 to that in 2008?
Offer a very short reply. 0.51. What is the ratio of the Imports (BoP, current US$) in Aruba in 2005 to that in 2008?
Give a very brief answer. 0.74. What is the ratio of the Imports (BoP, current US$) of French Polynesia in 2005 to that in 2008?
Your response must be concise. 0.81. What is the ratio of the Imports (BoP, current US$) of Guyana in 2005 to that in 2008?
Offer a terse response. 0.56. What is the ratio of the Imports (BoP, current US$) of Central Europe in 2005 to that in 2009?
Offer a terse response. 0.7. What is the ratio of the Imports (BoP, current US$) of Aruba in 2005 to that in 2009?
Offer a terse response. 1.59. What is the ratio of the Imports (BoP, current US$) in French Polynesia in 2005 to that in 2009?
Your response must be concise. 0.97. What is the ratio of the Imports (BoP, current US$) in Guyana in 2005 to that in 2009?
Your answer should be compact. 0.63. What is the ratio of the Imports (BoP, current US$) of Central Europe in 2005 to that in 2010?
Provide a short and direct response. 0.62. What is the ratio of the Imports (BoP, current US$) in Aruba in 2005 to that in 2010?
Offer a terse response. 2.42. What is the ratio of the Imports (BoP, current US$) in French Polynesia in 2005 to that in 2010?
Give a very brief answer. 0.99. What is the ratio of the Imports (BoP, current US$) of Guyana in 2005 to that in 2010?
Your answer should be compact. 0.55. What is the ratio of the Imports (BoP, current US$) of Central Europe in 2006 to that in 2007?
Ensure brevity in your answer.  0.77. What is the ratio of the Imports (BoP, current US$) of Aruba in 2006 to that in 2007?
Provide a succinct answer. 0.93. What is the ratio of the Imports (BoP, current US$) in French Polynesia in 2006 to that in 2007?
Provide a short and direct response. 0.89. What is the ratio of the Imports (BoP, current US$) of Guyana in 2006 to that in 2007?
Your answer should be very brief. 0.84. What is the ratio of the Imports (BoP, current US$) of Central Europe in 2006 to that in 2008?
Give a very brief answer. 0.62. What is the ratio of the Imports (BoP, current US$) in Aruba in 2006 to that in 2008?
Keep it short and to the point. 0.8. What is the ratio of the Imports (BoP, current US$) in French Polynesia in 2006 to that in 2008?
Provide a succinct answer. 0.75. What is the ratio of the Imports (BoP, current US$) of Guyana in 2006 to that in 2008?
Make the answer very short. 0.64. What is the ratio of the Imports (BoP, current US$) of Central Europe in 2006 to that in 2009?
Provide a short and direct response. 0.86. What is the ratio of the Imports (BoP, current US$) of Aruba in 2006 to that in 2009?
Your answer should be very brief. 1.74. What is the ratio of the Imports (BoP, current US$) of French Polynesia in 2006 to that in 2009?
Give a very brief answer. 0.91. What is the ratio of the Imports (BoP, current US$) of Guyana in 2006 to that in 2009?
Your response must be concise. 0.73. What is the ratio of the Imports (BoP, current US$) of Central Europe in 2006 to that in 2010?
Your answer should be very brief. 0.77. What is the ratio of the Imports (BoP, current US$) of Aruba in 2006 to that in 2010?
Make the answer very short. 2.64. What is the ratio of the Imports (BoP, current US$) of French Polynesia in 2006 to that in 2010?
Your response must be concise. 0.93. What is the ratio of the Imports (BoP, current US$) of Guyana in 2006 to that in 2010?
Offer a terse response. 0.64. What is the ratio of the Imports (BoP, current US$) of Central Europe in 2007 to that in 2008?
Make the answer very short. 0.81. What is the ratio of the Imports (BoP, current US$) of Aruba in 2007 to that in 2008?
Provide a succinct answer. 0.87. What is the ratio of the Imports (BoP, current US$) in French Polynesia in 2007 to that in 2008?
Give a very brief answer. 0.85. What is the ratio of the Imports (BoP, current US$) in Guyana in 2007 to that in 2008?
Make the answer very short. 0.76. What is the ratio of the Imports (BoP, current US$) in Central Europe in 2007 to that in 2009?
Ensure brevity in your answer.  1.12. What is the ratio of the Imports (BoP, current US$) in Aruba in 2007 to that in 2009?
Offer a very short reply. 1.88. What is the ratio of the Imports (BoP, current US$) in French Polynesia in 2007 to that in 2009?
Your response must be concise. 1.02. What is the ratio of the Imports (BoP, current US$) in Guyana in 2007 to that in 2009?
Keep it short and to the point. 0.86. What is the ratio of the Imports (BoP, current US$) of Central Europe in 2007 to that in 2010?
Keep it short and to the point. 1. What is the ratio of the Imports (BoP, current US$) of Aruba in 2007 to that in 2010?
Offer a terse response. 2.85. What is the ratio of the Imports (BoP, current US$) of French Polynesia in 2007 to that in 2010?
Give a very brief answer. 1.04. What is the ratio of the Imports (BoP, current US$) of Guyana in 2007 to that in 2010?
Provide a succinct answer. 0.76. What is the ratio of the Imports (BoP, current US$) of Central Europe in 2008 to that in 2009?
Offer a terse response. 1.38. What is the ratio of the Imports (BoP, current US$) in Aruba in 2008 to that in 2009?
Provide a succinct answer. 2.17. What is the ratio of the Imports (BoP, current US$) in French Polynesia in 2008 to that in 2009?
Make the answer very short. 1.21. What is the ratio of the Imports (BoP, current US$) in Guyana in 2008 to that in 2009?
Your answer should be compact. 1.14. What is the ratio of the Imports (BoP, current US$) of Central Europe in 2008 to that in 2010?
Ensure brevity in your answer.  1.23. What is the ratio of the Imports (BoP, current US$) in Aruba in 2008 to that in 2010?
Provide a succinct answer. 3.29. What is the ratio of the Imports (BoP, current US$) in French Polynesia in 2008 to that in 2010?
Make the answer very short. 1.23. What is the ratio of the Imports (BoP, current US$) in Guyana in 2008 to that in 2010?
Provide a succinct answer. 0.99. What is the ratio of the Imports (BoP, current US$) in Central Europe in 2009 to that in 2010?
Your response must be concise. 0.89. What is the ratio of the Imports (BoP, current US$) in Aruba in 2009 to that in 2010?
Provide a short and direct response. 1.52. What is the ratio of the Imports (BoP, current US$) in French Polynesia in 2009 to that in 2010?
Give a very brief answer. 1.02. What is the ratio of the Imports (BoP, current US$) in Guyana in 2009 to that in 2010?
Give a very brief answer. 0.88. What is the difference between the highest and the second highest Imports (BoP, current US$) in Central Europe?
Your answer should be very brief. 1.59e+11. What is the difference between the highest and the second highest Imports (BoP, current US$) of Aruba?
Offer a very short reply. 9.00e+08. What is the difference between the highest and the second highest Imports (BoP, current US$) of French Polynesia?
Ensure brevity in your answer.  4.33e+08. What is the difference between the highest and the second highest Imports (BoP, current US$) in Guyana?
Your answer should be very brief. 8.76e+06. What is the difference between the highest and the lowest Imports (BoP, current US$) of Central Europe?
Make the answer very short. 4.22e+11. What is the difference between the highest and the lowest Imports (BoP, current US$) in Aruba?
Make the answer very short. 4.74e+09. What is the difference between the highest and the lowest Imports (BoP, current US$) of French Polynesia?
Ensure brevity in your answer.  7.10e+08. What is the difference between the highest and the lowest Imports (BoP, current US$) in Guyana?
Provide a succinct answer. 7.40e+08. 